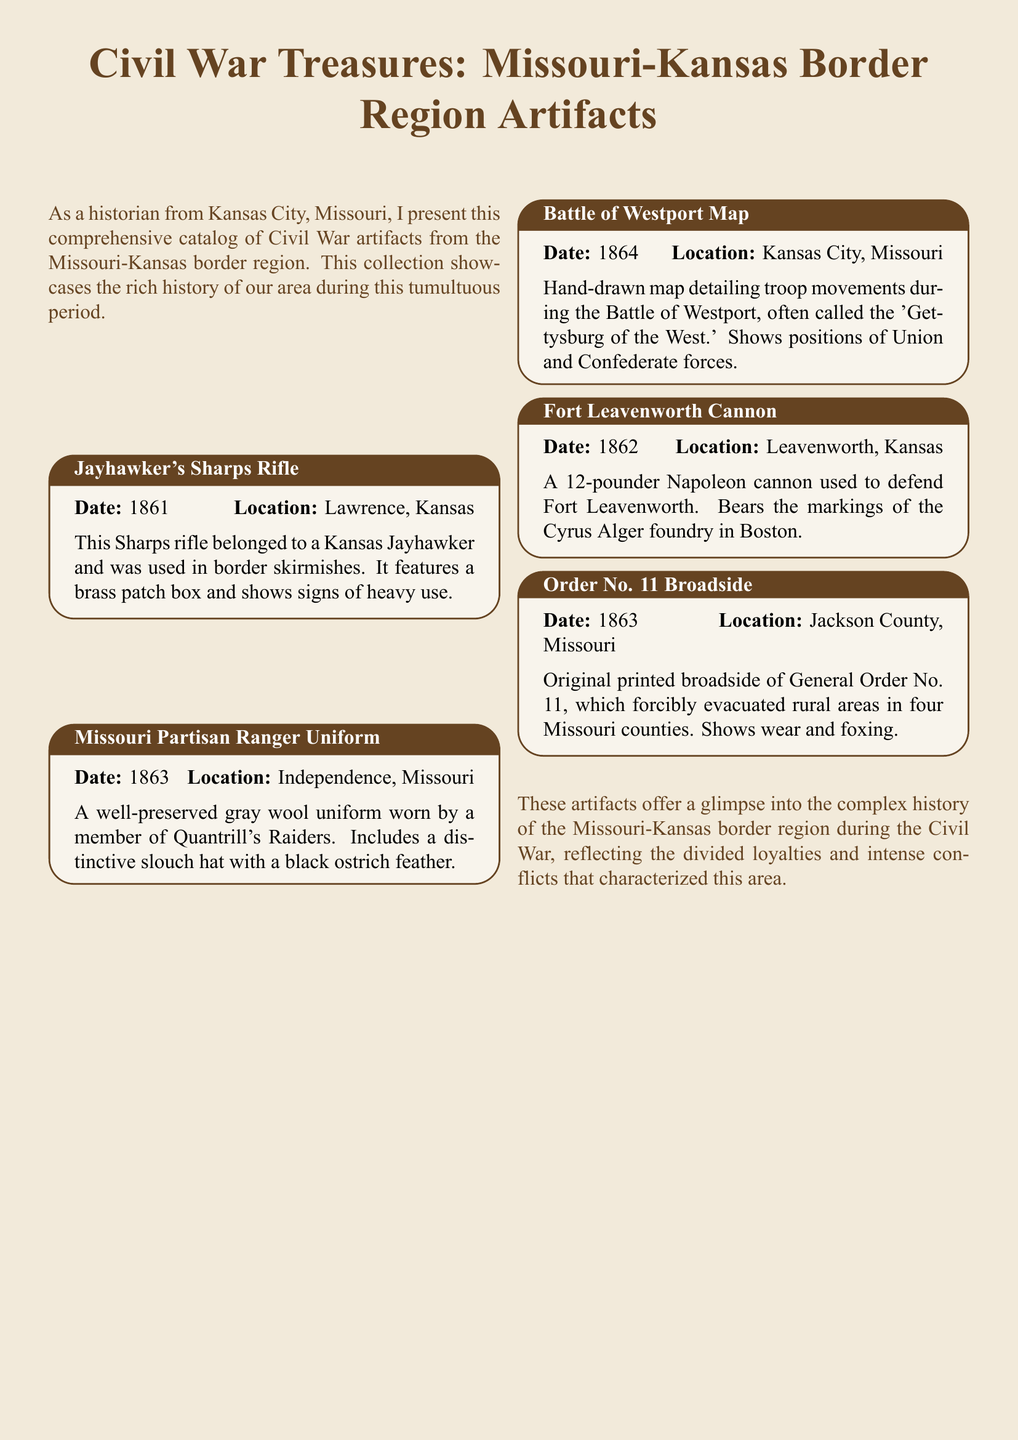What artifact belonged to a Kansas Jayhawker? The artifact descriptions include the Jayhawker's Sharps Rifle, which belonged to a Kansas Jayhawker and was used in border skirmishes.
Answer: Jayhawker's Sharps Rifle What year was the Missouri Partisan Ranger Uniform made? The year is listed next to each artifact, and the Missouri Partisan Ranger Uniform was dated 1863.
Answer: 1863 Where was the Battle of Westport Map created? The location is provided in the details for each artifact, and the Battle of Westport Map was created in Kansas City, Missouri.
Answer: Kansas City, Missouri Which artifact bears markings from the Cyrus Alger foundry? The Fort Leavenworth Cannon is specified to bear markings of the Cyrus Alger foundry in Boston.
Answer: Fort Leavenworth Cannon What event does the Order No. 11 Broadside relate to? The description of the Order No. 11 Broadside mentions it is related to the evacuation of rural areas in Missouri counties.
Answer: evacuation Which artifact shows signs of heavy use? The description for the Jayhawker's Sharps Rifle mentions that it shows signs of heavy use.
Answer: Jayhawker's Sharps Rifle How many artifacts are listed in the document? The document lists five artifacts in total.
Answer: five What type of cannon is the Fort Leavenworth Cannon? The description specifies it as a 12-pounder Napoleon cannon.
Answer: 12-pounder Napoleon cannon What color is the Missouri Partisan Ranger Uniform? The description mentions the uniform is gray, indicating its color.
Answer: gray 